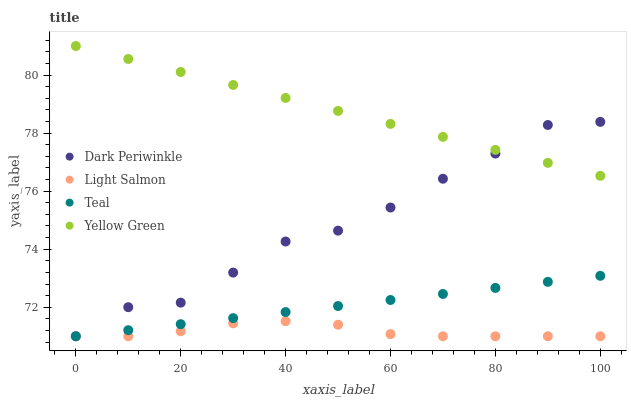Does Light Salmon have the minimum area under the curve?
Answer yes or no. Yes. Does Yellow Green have the maximum area under the curve?
Answer yes or no. Yes. Does Dark Periwinkle have the minimum area under the curve?
Answer yes or no. No. Does Dark Periwinkle have the maximum area under the curve?
Answer yes or no. No. Is Teal the smoothest?
Answer yes or no. Yes. Is Dark Periwinkle the roughest?
Answer yes or no. Yes. Is Dark Periwinkle the smoothest?
Answer yes or no. No. Is Teal the roughest?
Answer yes or no. No. Does Light Salmon have the lowest value?
Answer yes or no. Yes. Does Yellow Green have the lowest value?
Answer yes or no. No. Does Yellow Green have the highest value?
Answer yes or no. Yes. Does Dark Periwinkle have the highest value?
Answer yes or no. No. Is Teal less than Yellow Green?
Answer yes or no. Yes. Is Yellow Green greater than Teal?
Answer yes or no. Yes. Does Dark Periwinkle intersect Teal?
Answer yes or no. Yes. Is Dark Periwinkle less than Teal?
Answer yes or no. No. Is Dark Periwinkle greater than Teal?
Answer yes or no. No. Does Teal intersect Yellow Green?
Answer yes or no. No. 